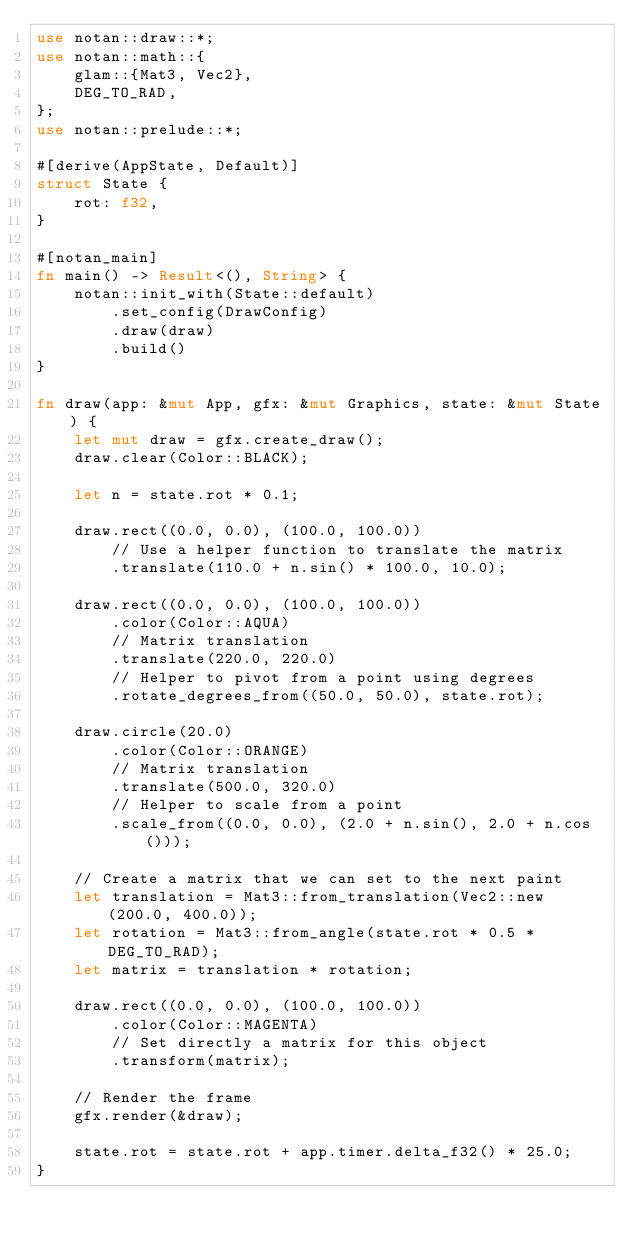<code> <loc_0><loc_0><loc_500><loc_500><_Rust_>use notan::draw::*;
use notan::math::{
    glam::{Mat3, Vec2},
    DEG_TO_RAD,
};
use notan::prelude::*;

#[derive(AppState, Default)]
struct State {
    rot: f32,
}

#[notan_main]
fn main() -> Result<(), String> {
    notan::init_with(State::default)
        .set_config(DrawConfig)
        .draw(draw)
        .build()
}

fn draw(app: &mut App, gfx: &mut Graphics, state: &mut State) {
    let mut draw = gfx.create_draw();
    draw.clear(Color::BLACK);

    let n = state.rot * 0.1;

    draw.rect((0.0, 0.0), (100.0, 100.0))
        // Use a helper function to translate the matrix
        .translate(110.0 + n.sin() * 100.0, 10.0);

    draw.rect((0.0, 0.0), (100.0, 100.0))
        .color(Color::AQUA)
        // Matrix translation
        .translate(220.0, 220.0)
        // Helper to pivot from a point using degrees
        .rotate_degrees_from((50.0, 50.0), state.rot);

    draw.circle(20.0)
        .color(Color::ORANGE)
        // Matrix translation
        .translate(500.0, 320.0)
        // Helper to scale from a point
        .scale_from((0.0, 0.0), (2.0 + n.sin(), 2.0 + n.cos()));

    // Create a matrix that we can set to the next paint
    let translation = Mat3::from_translation(Vec2::new(200.0, 400.0));
    let rotation = Mat3::from_angle(state.rot * 0.5 * DEG_TO_RAD);
    let matrix = translation * rotation;

    draw.rect((0.0, 0.0), (100.0, 100.0))
        .color(Color::MAGENTA)
        // Set directly a matrix for this object
        .transform(matrix);

    // Render the frame
    gfx.render(&draw);

    state.rot = state.rot + app.timer.delta_f32() * 25.0;
}
</code> 